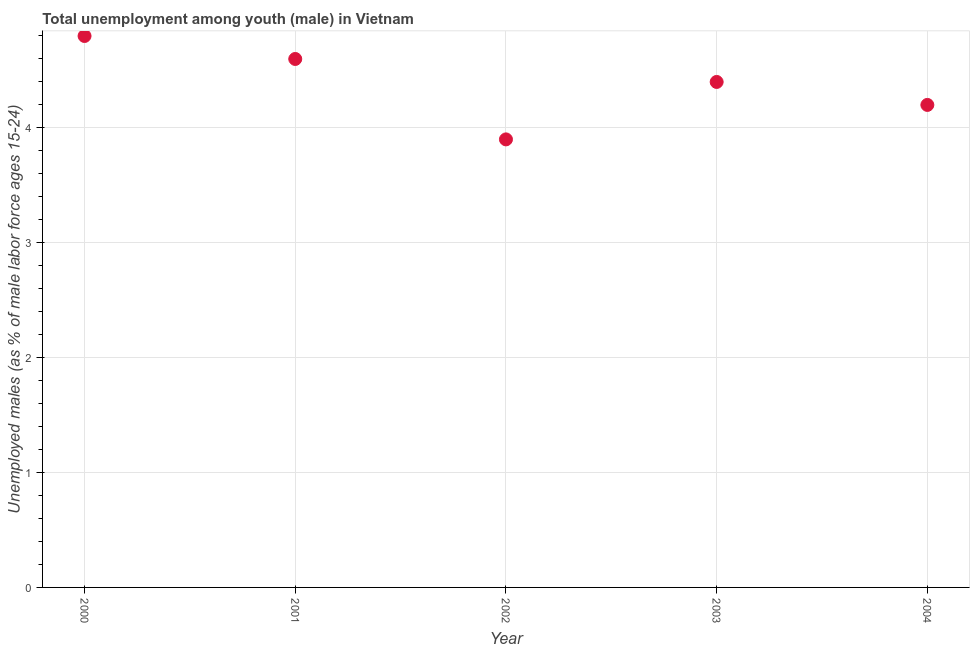What is the unemployed male youth population in 2004?
Make the answer very short. 4.2. Across all years, what is the maximum unemployed male youth population?
Give a very brief answer. 4.8. Across all years, what is the minimum unemployed male youth population?
Your response must be concise. 3.9. In which year was the unemployed male youth population maximum?
Ensure brevity in your answer.  2000. What is the sum of the unemployed male youth population?
Provide a short and direct response. 21.9. What is the difference between the unemployed male youth population in 2001 and 2004?
Provide a short and direct response. 0.4. What is the average unemployed male youth population per year?
Give a very brief answer. 4.38. What is the median unemployed male youth population?
Your answer should be compact. 4.4. What is the ratio of the unemployed male youth population in 2002 to that in 2004?
Offer a very short reply. 0.93. Is the difference between the unemployed male youth population in 2003 and 2004 greater than the difference between any two years?
Your answer should be very brief. No. What is the difference between the highest and the second highest unemployed male youth population?
Offer a terse response. 0.2. Is the sum of the unemployed male youth population in 2002 and 2003 greater than the maximum unemployed male youth population across all years?
Offer a very short reply. Yes. What is the difference between the highest and the lowest unemployed male youth population?
Provide a succinct answer. 0.9. In how many years, is the unemployed male youth population greater than the average unemployed male youth population taken over all years?
Your answer should be very brief. 3. Does the unemployed male youth population monotonically increase over the years?
Offer a terse response. No. How many dotlines are there?
Keep it short and to the point. 1. Does the graph contain any zero values?
Make the answer very short. No. What is the title of the graph?
Offer a very short reply. Total unemployment among youth (male) in Vietnam. What is the label or title of the Y-axis?
Keep it short and to the point. Unemployed males (as % of male labor force ages 15-24). What is the Unemployed males (as % of male labor force ages 15-24) in 2000?
Ensure brevity in your answer.  4.8. What is the Unemployed males (as % of male labor force ages 15-24) in 2001?
Keep it short and to the point. 4.6. What is the Unemployed males (as % of male labor force ages 15-24) in 2002?
Your response must be concise. 3.9. What is the Unemployed males (as % of male labor force ages 15-24) in 2003?
Your response must be concise. 4.4. What is the Unemployed males (as % of male labor force ages 15-24) in 2004?
Your answer should be compact. 4.2. What is the difference between the Unemployed males (as % of male labor force ages 15-24) in 2000 and 2001?
Your answer should be very brief. 0.2. What is the difference between the Unemployed males (as % of male labor force ages 15-24) in 2000 and 2002?
Ensure brevity in your answer.  0.9. What is the difference between the Unemployed males (as % of male labor force ages 15-24) in 2000 and 2003?
Your answer should be very brief. 0.4. What is the difference between the Unemployed males (as % of male labor force ages 15-24) in 2000 and 2004?
Provide a short and direct response. 0.6. What is the difference between the Unemployed males (as % of male labor force ages 15-24) in 2002 and 2003?
Ensure brevity in your answer.  -0.5. What is the difference between the Unemployed males (as % of male labor force ages 15-24) in 2002 and 2004?
Make the answer very short. -0.3. What is the ratio of the Unemployed males (as % of male labor force ages 15-24) in 2000 to that in 2001?
Offer a very short reply. 1.04. What is the ratio of the Unemployed males (as % of male labor force ages 15-24) in 2000 to that in 2002?
Your answer should be very brief. 1.23. What is the ratio of the Unemployed males (as % of male labor force ages 15-24) in 2000 to that in 2003?
Make the answer very short. 1.09. What is the ratio of the Unemployed males (as % of male labor force ages 15-24) in 2000 to that in 2004?
Offer a very short reply. 1.14. What is the ratio of the Unemployed males (as % of male labor force ages 15-24) in 2001 to that in 2002?
Offer a very short reply. 1.18. What is the ratio of the Unemployed males (as % of male labor force ages 15-24) in 2001 to that in 2003?
Offer a very short reply. 1.04. What is the ratio of the Unemployed males (as % of male labor force ages 15-24) in 2001 to that in 2004?
Make the answer very short. 1.09. What is the ratio of the Unemployed males (as % of male labor force ages 15-24) in 2002 to that in 2003?
Give a very brief answer. 0.89. What is the ratio of the Unemployed males (as % of male labor force ages 15-24) in 2002 to that in 2004?
Provide a short and direct response. 0.93. What is the ratio of the Unemployed males (as % of male labor force ages 15-24) in 2003 to that in 2004?
Make the answer very short. 1.05. 